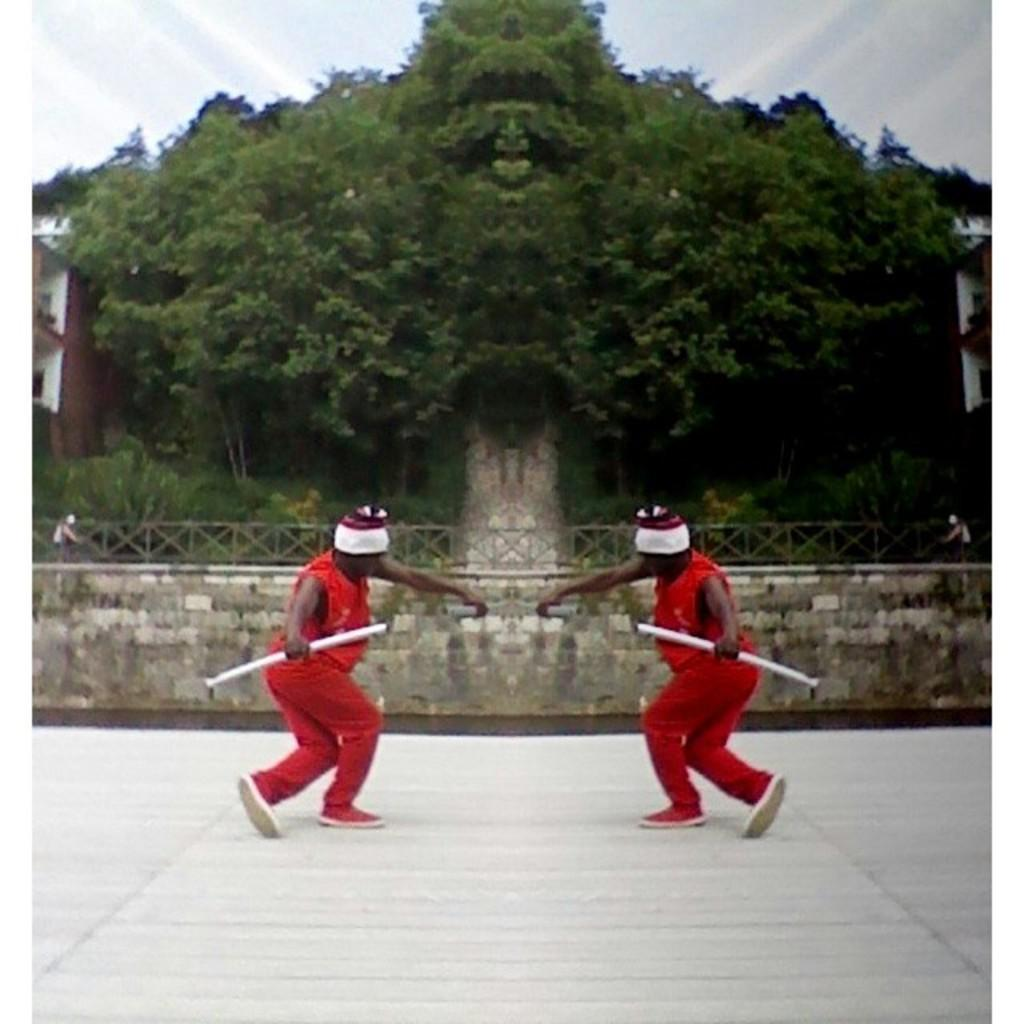What is located in the middle of the image? There are trees and two persons in the middle of the image. What are the two persons wearing? The two persons are wearing the same dress. What is visible at the top of the image? The sky is visible at the top of the image. What type of sheet is being used by the servant in the image? There is no servant or sheet present in the image. What board game are the two persons playing in the image? There is no board game or indication of any game being played in the image. 